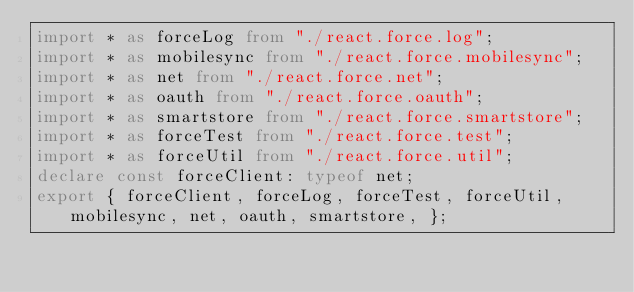Convert code to text. <code><loc_0><loc_0><loc_500><loc_500><_TypeScript_>import * as forceLog from "./react.force.log";
import * as mobilesync from "./react.force.mobilesync";
import * as net from "./react.force.net";
import * as oauth from "./react.force.oauth";
import * as smartstore from "./react.force.smartstore";
import * as forceTest from "./react.force.test";
import * as forceUtil from "./react.force.util";
declare const forceClient: typeof net;
export { forceClient, forceLog, forceTest, forceUtil, mobilesync, net, oauth, smartstore, };
</code> 